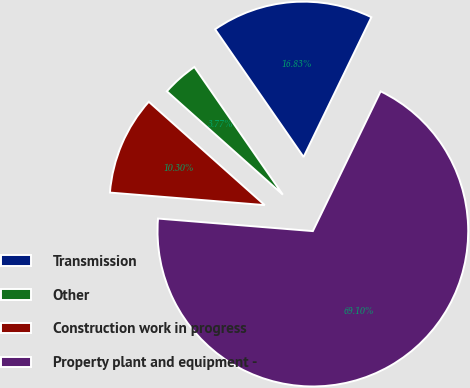<chart> <loc_0><loc_0><loc_500><loc_500><pie_chart><fcel>Transmission<fcel>Other<fcel>Construction work in progress<fcel>Property plant and equipment -<nl><fcel>16.83%<fcel>3.77%<fcel>10.3%<fcel>69.1%<nl></chart> 